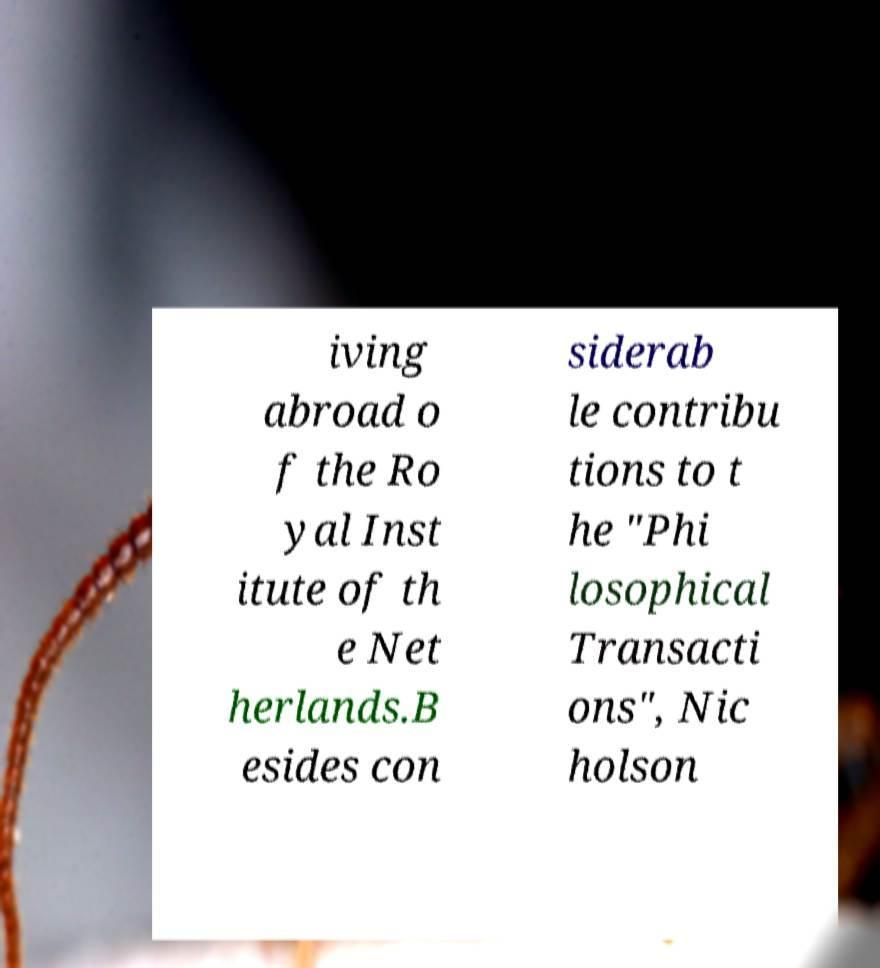Please identify and transcribe the text found in this image. iving abroad o f the Ro yal Inst itute of th e Net herlands.B esides con siderab le contribu tions to t he "Phi losophical Transacti ons", Nic holson 